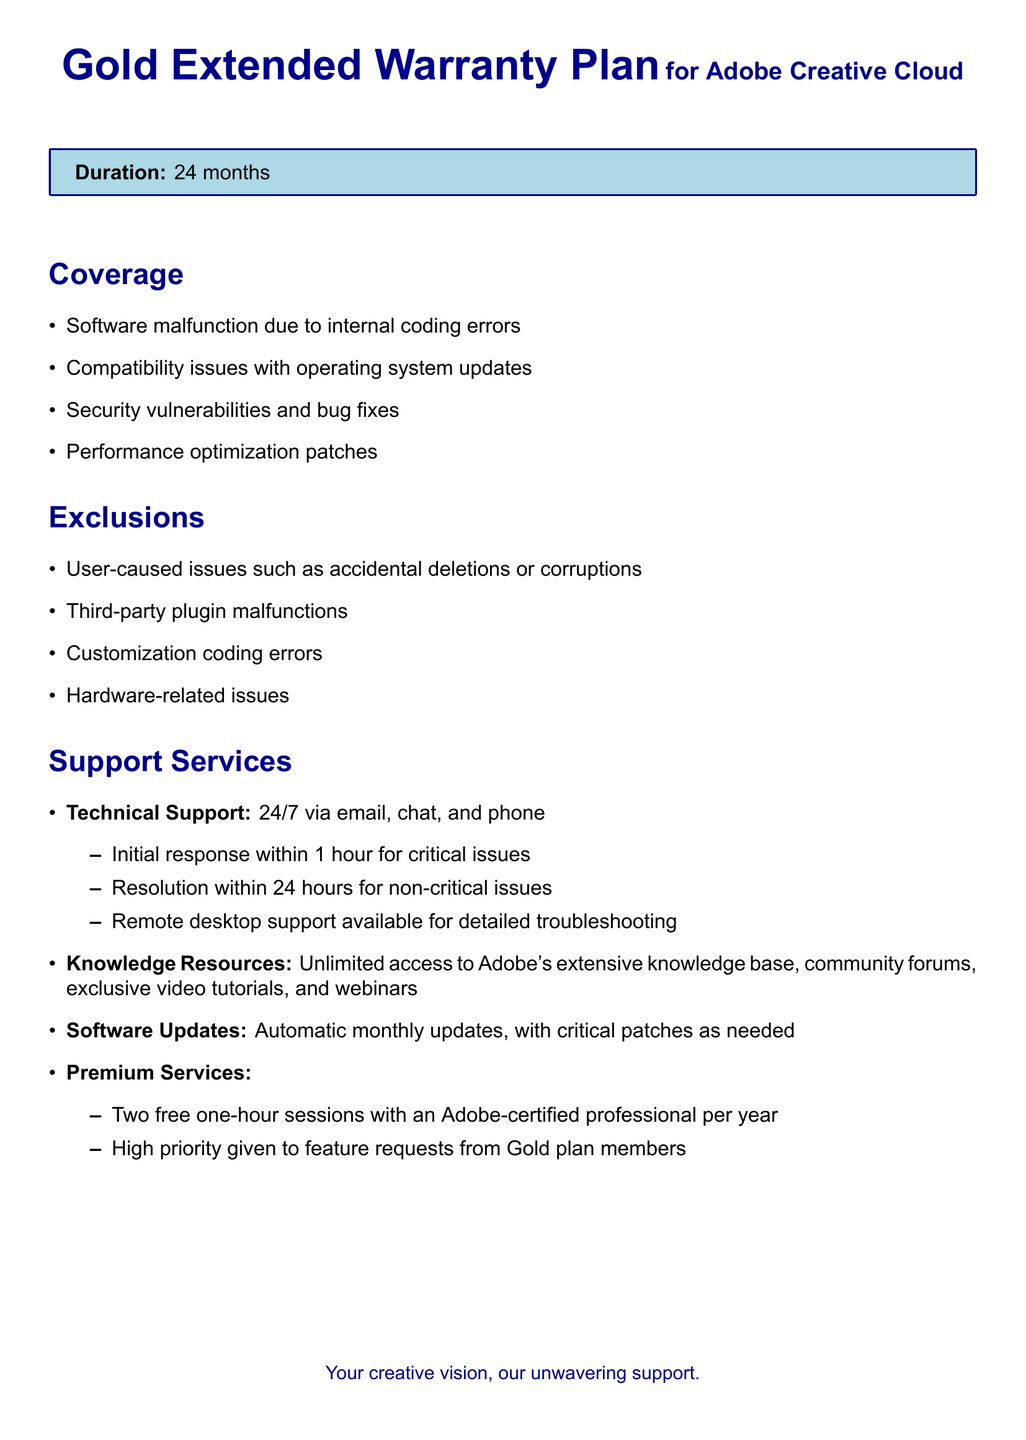What is the duration of the warranty? The duration of the warranty is explicitly stated in the document as 24 months.
Answer: 24 months What type of support is offered for critical issues? The document specifies that initial response for critical issues is within 1 hour.
Answer: 1 hour What are the exclusions listed in the warranty? The document outlines specific exclusions, such as user-caused issues and third-party plugin malfunctions.
Answer: User-caused issues What kind of updates are included in the warranty? The document mentions that automatic monthly updates and critical patches are part of the support services.
Answer: Automatic monthly updates How many free sessions with an Adobe-certified professional are included per year? The warranty states that two free sessions with an Adobe-certified professional are provided each year.
Answer: Two What support services are available 24/7? The document highlights that technical support is available 24/7 via email, chat, and phone.
Answer: Technical Support What does the warranty cover in terms of software performance? The warranty covers performance optimization patches among other issues.
Answer: Performance optimization patches What resource access is unlimited according to the document? The document specifically states unlimited access to Adobe's knowledge base and community forums.
Answer: Adobe's knowledge base What is the response time for non-critical issues? The document notes that the resolution for non-critical issues is within 24 hours.
Answer: 24 hours 